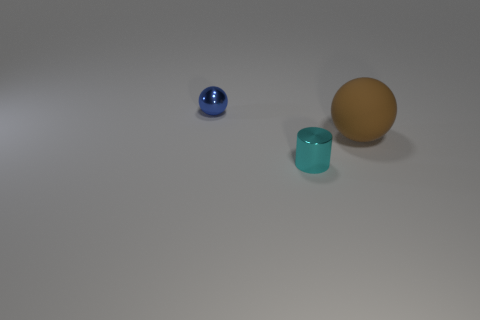Add 2 rubber things. How many objects exist? 5 Subtract all cylinders. How many objects are left? 2 Add 3 tiny cyan cylinders. How many tiny cyan cylinders are left? 4 Add 3 small metallic objects. How many small metallic objects exist? 5 Subtract 0 red cylinders. How many objects are left? 3 Subtract all spheres. Subtract all cylinders. How many objects are left? 0 